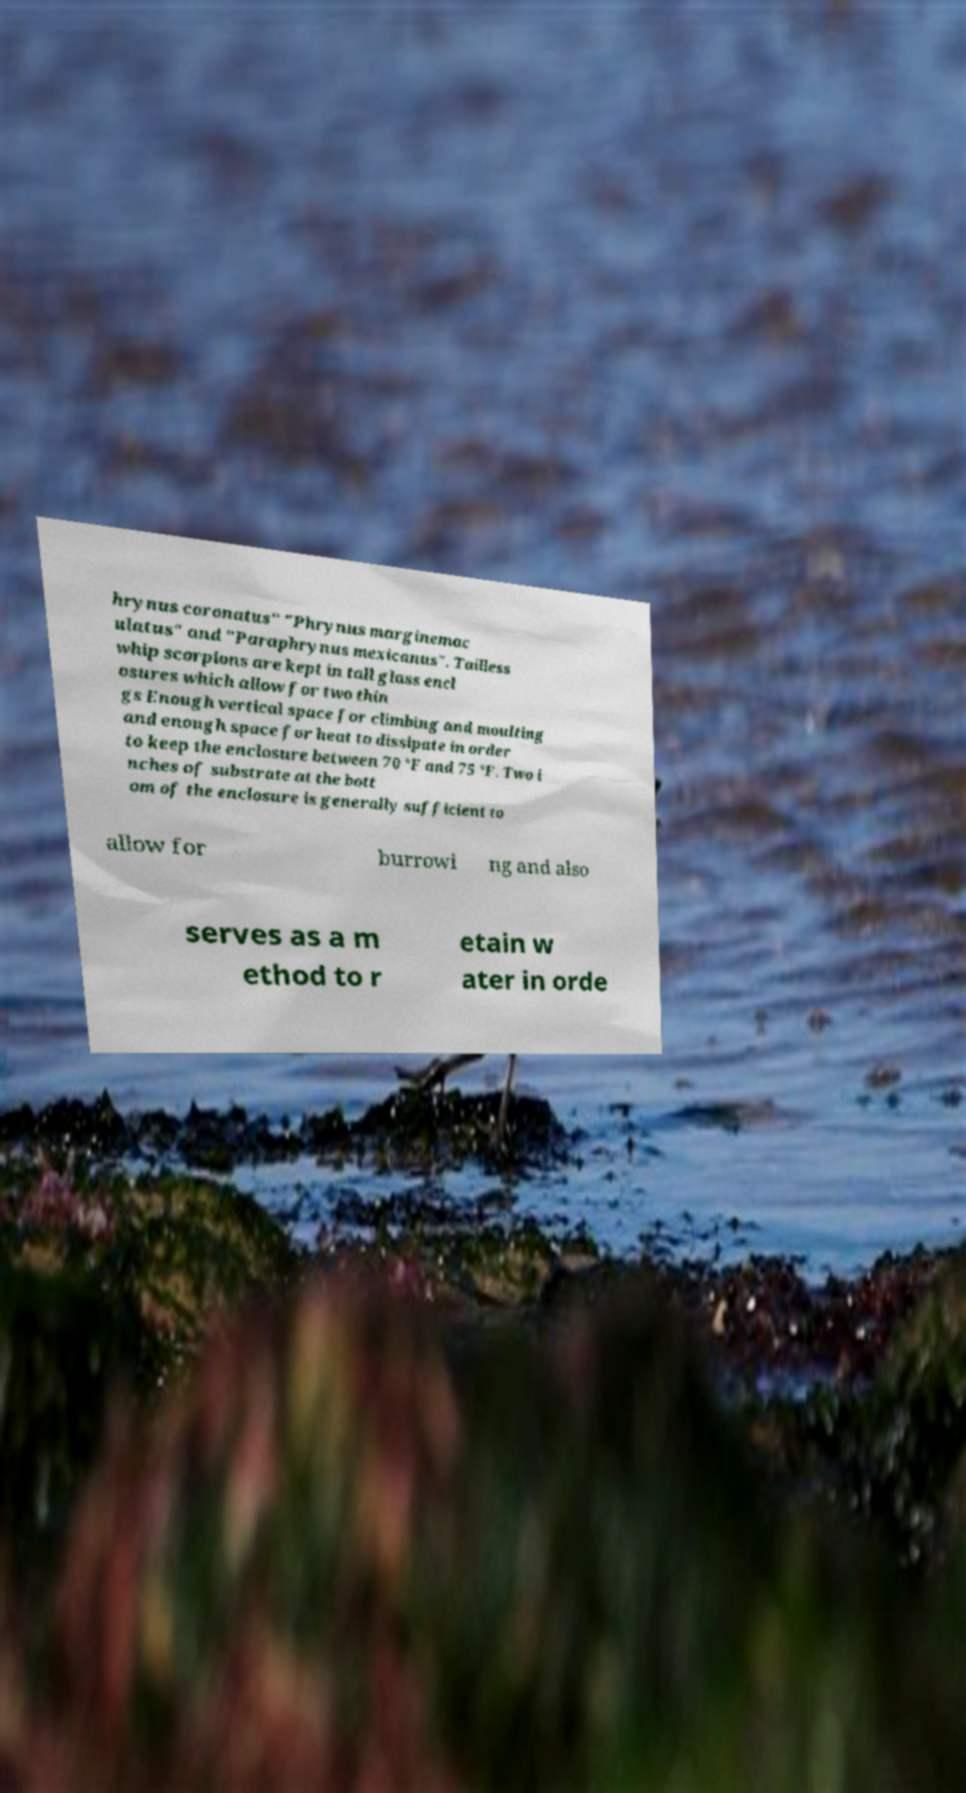Could you assist in decoding the text presented in this image and type it out clearly? hrynus coronatus" "Phrynus marginemac ulatus" and "Paraphrynus mexicanus". Tailless whip scorpions are kept in tall glass encl osures which allow for two thin gs Enough vertical space for climbing and moulting and enough space for heat to dissipate in order to keep the enclosure between 70 °F and 75 °F. Two i nches of substrate at the bott om of the enclosure is generally sufficient to allow for burrowi ng and also serves as a m ethod to r etain w ater in orde 